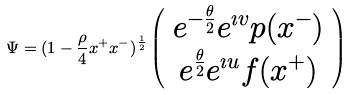Convert formula to latex. <formula><loc_0><loc_0><loc_500><loc_500>\Psi = ( 1 - { \frac { \rho } { 4 } } x ^ { + } x ^ { - } ) ^ { \frac { 1 } { 2 } } \left ( \begin{array} { c } { { e ^ { - { \frac { \theta } { 2 } } } e ^ { \imath v } p ( x ^ { - } ) } } \\ { { e ^ { { \frac { \theta } { 2 } } } e ^ { \imath u } f ( x ^ { + } ) } } \end{array} \right )</formula> 